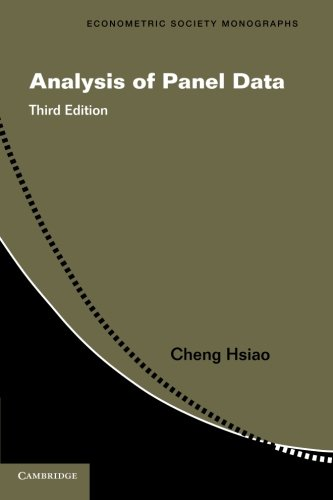What type of book is this? This book is primarily an academic text focused on econometrics, specifically on the statistical analysis of panel data, though it also intersects with the broader fields of economics and business studies. 